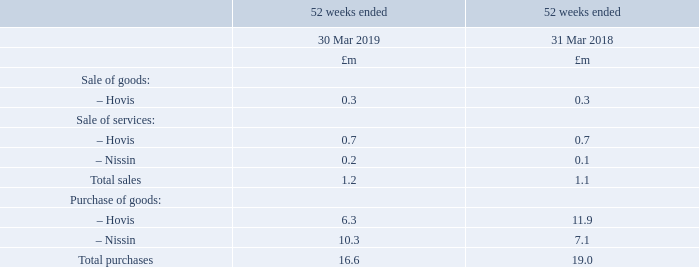The Group’s associates are considered to be related parties.
As at 30 March 2019 the following are also considered to be related parties under the Listing Rules due to their shareholdings exceeding 10% of the Group’s total issued share capital:
− Nissin Foods Holdings Co., Ltd. (“Nissin”) is considered to be a related party to the Group by virtue of its 19.47% (2017/18: 19.57%) equity shareholding in Premier Foods plc and of its power to appoint a member to the Board of directors.− Oasis Management Company Ltd (“Oasis”) is considered to be a related party to the Group by virtue of its 11.99% (2017/18: 9.01%) equity shareholding in Premier Foods plc and of its power to appoint a member to the Board of directors.
− Paulson Investment Company LLC, (“Paulson”) is considered to be a related party to the Group by virtue of its 11.98% (2017/18: 7.39%) equity shareholding in Premier Foods plc and of its power to appoint a member to the Board of directors.
As at 30 March 2019 the Group had outstanding balances with Hovis. Total trade receivables was £0.9m (2017/18: £0.5m) and total trade payables was £0.6m (2017/18: £2.5m).
What was the equity shareholding of Nissin Food Holdings Co., Ltd. in Premier Foods plc in 2019? 19.47%. What was the total trade receivables in 2019? £0.9m. What was the hovis sale of goods in 2019?
Answer scale should be: million. 0.3. What was the change in hovis sale of goods from 2018 to 2019?
Answer scale should be: million. 0.3 - 0.3
Answer: 0. What is the average hovis sale of services for 2018 and 2019?
Answer scale should be: million. (0.7 + 0.7) / 2
Answer: 0.7. What is the average hovis purchase of goods for 2018 and 2019?
Answer scale should be: million. (6.3 + 11.9) / 2
Answer: 9.1. 